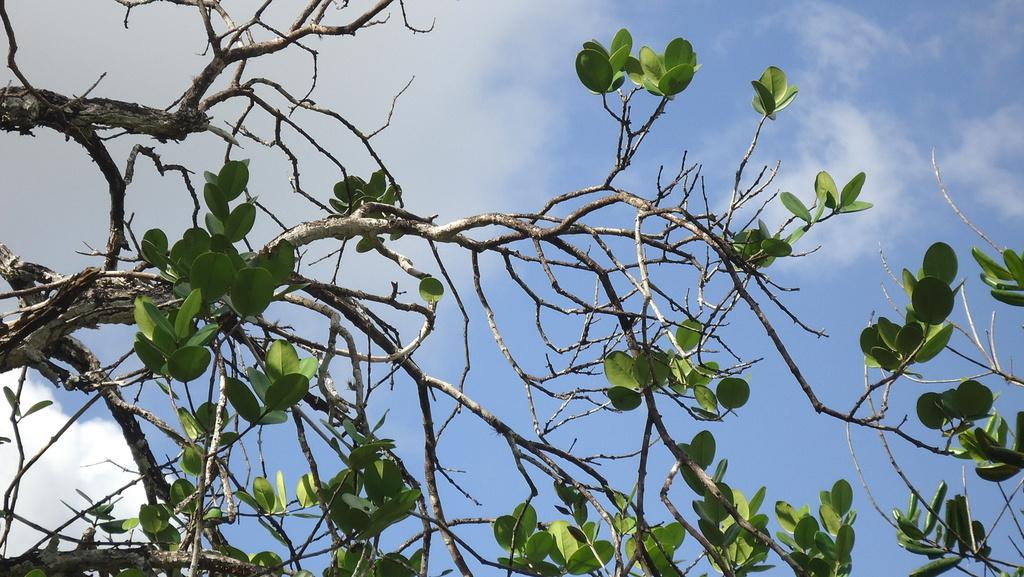What type of vegetation is present in the image? There are branches of a tree with leaves in the image. What part of the natural environment is visible in the image? The sky is visible in the image. How would you describe the sky in the image? The sky appears cloudy in the image. Can you see any ants crawling on the leaves in the image? There is no mention of ants in the image, so we cannot determine if any are present. How long does it take for the leaves to cry in the image? Leaves do not have the ability to cry, so this question is not applicable to the image. 